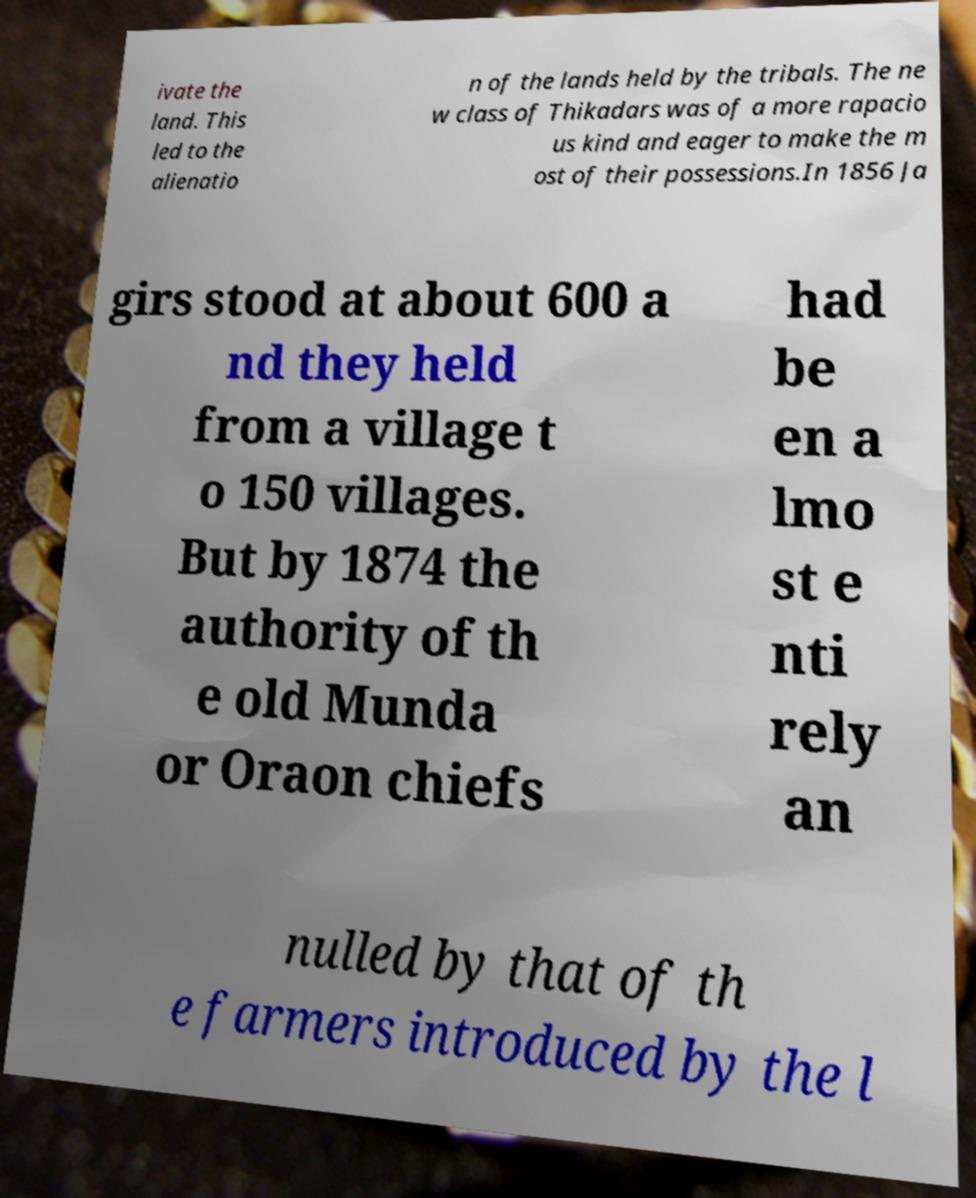Please read and relay the text visible in this image. What does it say? ivate the land. This led to the alienatio n of the lands held by the tribals. The ne w class of Thikadars was of a more rapacio us kind and eager to make the m ost of their possessions.In 1856 Ja girs stood at about 600 a nd they held from a village t o 150 villages. But by 1874 the authority of th e old Munda or Oraon chiefs had be en a lmo st e nti rely an nulled by that of th e farmers introduced by the l 